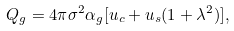Convert formula to latex. <formula><loc_0><loc_0><loc_500><loc_500>Q _ { g } = 4 \pi \sigma ^ { 2 } \alpha _ { g } [ u _ { c } + u _ { s } ( 1 + \lambda ^ { 2 } ) ] ,</formula> 